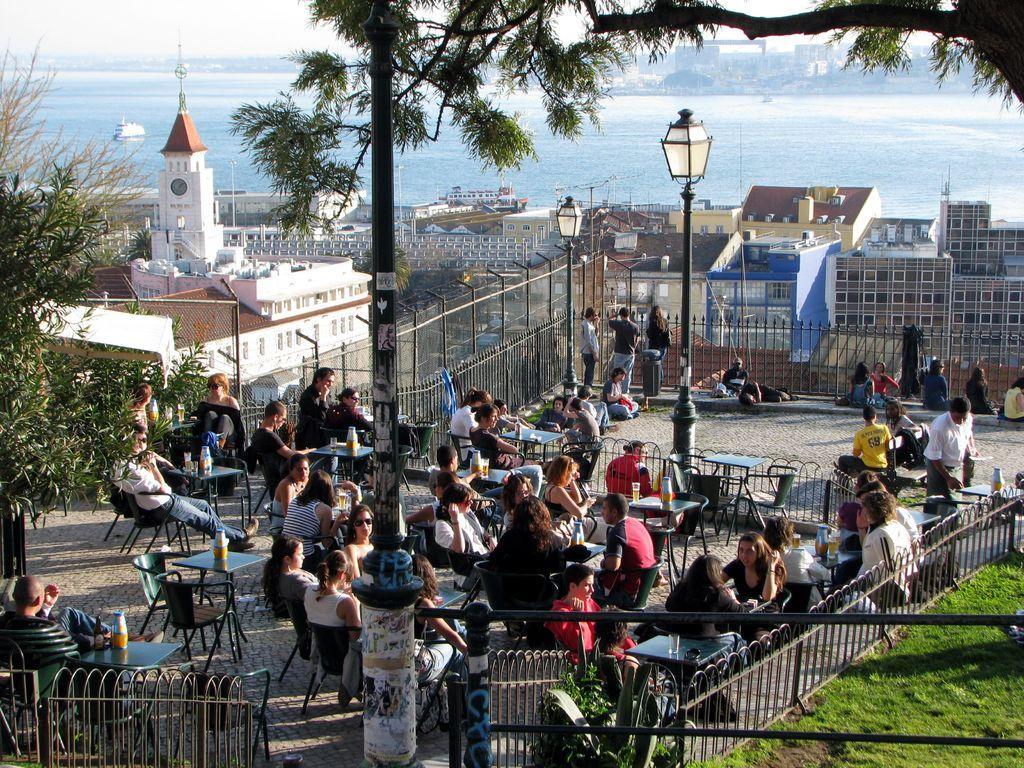Please provide a concise description of this image. Here we can see few people sitting on the chairs at the tables. On the tables we can see glasses,bottles and some other items. In the background there are buildings,light poles,fence,grass,plants and we can also there persons standing at the fence,trees,boats on the water and sky. 